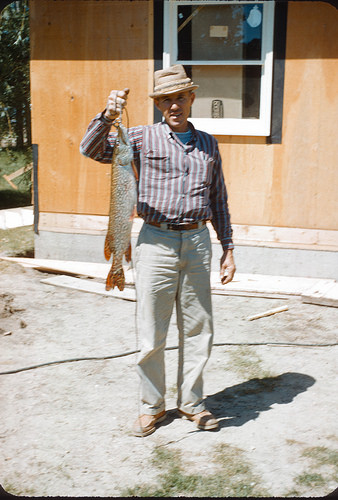<image>
Is the fish on the man? No. The fish is not positioned on the man. They may be near each other, but the fish is not supported by or resting on top of the man. Is there a man behind the fish? Yes. From this viewpoint, the man is positioned behind the fish, with the fish partially or fully occluding the man. Is there a guy behind the fish? Yes. From this viewpoint, the guy is positioned behind the fish, with the fish partially or fully occluding the guy. 